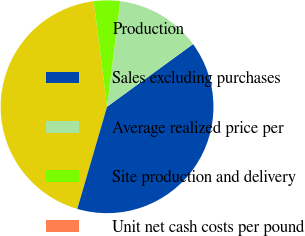<chart> <loc_0><loc_0><loc_500><loc_500><pie_chart><fcel>Production<fcel>Sales excluding purchases<fcel>Average realized price per<fcel>Site production and delivery<fcel>Unit net cash costs per pound<nl><fcel>43.49%<fcel>39.53%<fcel>13.01%<fcel>3.97%<fcel>0.01%<nl></chart> 